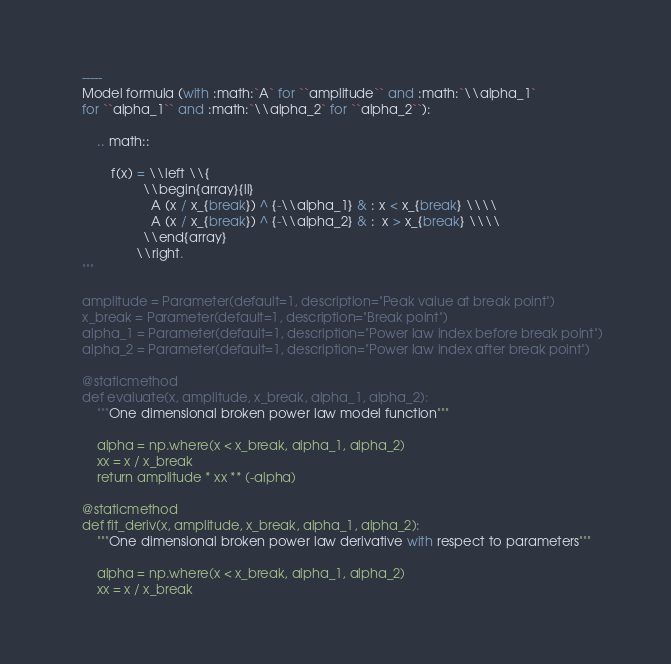Convert code to text. <code><loc_0><loc_0><loc_500><loc_500><_Python_>    -----
    Model formula (with :math:`A` for ``amplitude`` and :math:`\\alpha_1`
    for ``alpha_1`` and :math:`\\alpha_2` for ``alpha_2``):

        .. math::

            f(x) = \\left \\{
                     \\begin{array}{ll}
                       A (x / x_{break}) ^ {-\\alpha_1} & : x < x_{break} \\\\
                       A (x / x_{break}) ^ {-\\alpha_2} & :  x > x_{break} \\\\
                     \\end{array}
                   \\right.
    """

    amplitude = Parameter(default=1, description="Peak value at break point")
    x_break = Parameter(default=1, description="Break point")
    alpha_1 = Parameter(default=1, description="Power law index before break point")
    alpha_2 = Parameter(default=1, description="Power law index after break point")

    @staticmethod
    def evaluate(x, amplitude, x_break, alpha_1, alpha_2):
        """One dimensional broken power law model function"""

        alpha = np.where(x < x_break, alpha_1, alpha_2)
        xx = x / x_break
        return amplitude * xx ** (-alpha)

    @staticmethod
    def fit_deriv(x, amplitude, x_break, alpha_1, alpha_2):
        """One dimensional broken power law derivative with respect to parameters"""

        alpha = np.where(x < x_break, alpha_1, alpha_2)
        xx = x / x_break
</code> 